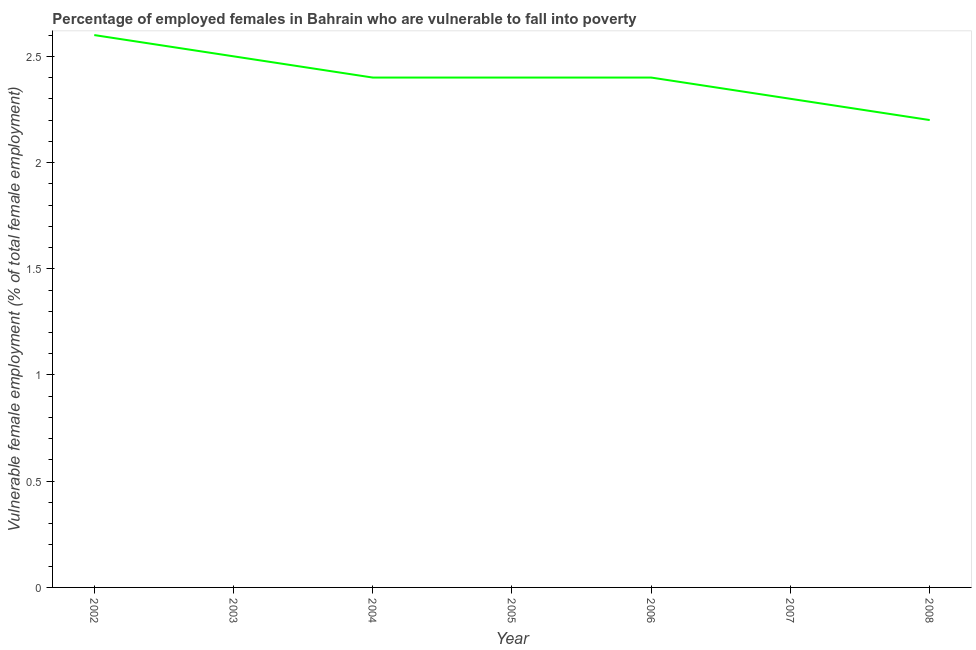What is the percentage of employed females who are vulnerable to fall into poverty in 2005?
Your answer should be compact. 2.4. Across all years, what is the maximum percentage of employed females who are vulnerable to fall into poverty?
Your response must be concise. 2.6. Across all years, what is the minimum percentage of employed females who are vulnerable to fall into poverty?
Your answer should be compact. 2.2. What is the sum of the percentage of employed females who are vulnerable to fall into poverty?
Keep it short and to the point. 16.8. What is the difference between the percentage of employed females who are vulnerable to fall into poverty in 2002 and 2006?
Provide a succinct answer. 0.2. What is the average percentage of employed females who are vulnerable to fall into poverty per year?
Provide a succinct answer. 2.4. What is the median percentage of employed females who are vulnerable to fall into poverty?
Your answer should be compact. 2.4. Do a majority of the years between 2006 and 2004 (inclusive) have percentage of employed females who are vulnerable to fall into poverty greater than 0.6 %?
Make the answer very short. No. What is the ratio of the percentage of employed females who are vulnerable to fall into poverty in 2007 to that in 2008?
Ensure brevity in your answer.  1.05. What is the difference between the highest and the second highest percentage of employed females who are vulnerable to fall into poverty?
Your answer should be compact. 0.1. What is the difference between the highest and the lowest percentage of employed females who are vulnerable to fall into poverty?
Your response must be concise. 0.4. In how many years, is the percentage of employed females who are vulnerable to fall into poverty greater than the average percentage of employed females who are vulnerable to fall into poverty taken over all years?
Your answer should be compact. 5. What is the difference between two consecutive major ticks on the Y-axis?
Offer a very short reply. 0.5. Does the graph contain any zero values?
Keep it short and to the point. No. Does the graph contain grids?
Your response must be concise. No. What is the title of the graph?
Offer a terse response. Percentage of employed females in Bahrain who are vulnerable to fall into poverty. What is the label or title of the X-axis?
Your answer should be very brief. Year. What is the label or title of the Y-axis?
Your response must be concise. Vulnerable female employment (% of total female employment). What is the Vulnerable female employment (% of total female employment) of 2002?
Your answer should be compact. 2.6. What is the Vulnerable female employment (% of total female employment) in 2004?
Provide a short and direct response. 2.4. What is the Vulnerable female employment (% of total female employment) in 2005?
Provide a short and direct response. 2.4. What is the Vulnerable female employment (% of total female employment) of 2006?
Your response must be concise. 2.4. What is the Vulnerable female employment (% of total female employment) in 2007?
Provide a succinct answer. 2.3. What is the Vulnerable female employment (% of total female employment) of 2008?
Ensure brevity in your answer.  2.2. What is the difference between the Vulnerable female employment (% of total female employment) in 2002 and 2003?
Ensure brevity in your answer.  0.1. What is the difference between the Vulnerable female employment (% of total female employment) in 2002 and 2004?
Offer a very short reply. 0.2. What is the difference between the Vulnerable female employment (% of total female employment) in 2002 and 2006?
Your answer should be compact. 0.2. What is the difference between the Vulnerable female employment (% of total female employment) in 2003 and 2004?
Offer a terse response. 0.1. What is the difference between the Vulnerable female employment (% of total female employment) in 2003 and 2006?
Provide a succinct answer. 0.1. What is the difference between the Vulnerable female employment (% of total female employment) in 2003 and 2007?
Your response must be concise. 0.2. What is the difference between the Vulnerable female employment (% of total female employment) in 2004 and 2006?
Offer a very short reply. 0. What is the difference between the Vulnerable female employment (% of total female employment) in 2004 and 2007?
Your answer should be compact. 0.1. What is the difference between the Vulnerable female employment (% of total female employment) in 2004 and 2008?
Give a very brief answer. 0.2. What is the difference between the Vulnerable female employment (% of total female employment) in 2005 and 2006?
Keep it short and to the point. 0. What is the difference between the Vulnerable female employment (% of total female employment) in 2005 and 2007?
Offer a terse response. 0.1. What is the difference between the Vulnerable female employment (% of total female employment) in 2005 and 2008?
Offer a terse response. 0.2. What is the ratio of the Vulnerable female employment (% of total female employment) in 2002 to that in 2003?
Provide a succinct answer. 1.04. What is the ratio of the Vulnerable female employment (% of total female employment) in 2002 to that in 2004?
Offer a very short reply. 1.08. What is the ratio of the Vulnerable female employment (% of total female employment) in 2002 to that in 2005?
Your response must be concise. 1.08. What is the ratio of the Vulnerable female employment (% of total female employment) in 2002 to that in 2006?
Your answer should be very brief. 1.08. What is the ratio of the Vulnerable female employment (% of total female employment) in 2002 to that in 2007?
Provide a succinct answer. 1.13. What is the ratio of the Vulnerable female employment (% of total female employment) in 2002 to that in 2008?
Make the answer very short. 1.18. What is the ratio of the Vulnerable female employment (% of total female employment) in 2003 to that in 2004?
Ensure brevity in your answer.  1.04. What is the ratio of the Vulnerable female employment (% of total female employment) in 2003 to that in 2005?
Offer a very short reply. 1.04. What is the ratio of the Vulnerable female employment (% of total female employment) in 2003 to that in 2006?
Provide a succinct answer. 1.04. What is the ratio of the Vulnerable female employment (% of total female employment) in 2003 to that in 2007?
Offer a terse response. 1.09. What is the ratio of the Vulnerable female employment (% of total female employment) in 2003 to that in 2008?
Provide a succinct answer. 1.14. What is the ratio of the Vulnerable female employment (% of total female employment) in 2004 to that in 2007?
Your response must be concise. 1.04. What is the ratio of the Vulnerable female employment (% of total female employment) in 2004 to that in 2008?
Make the answer very short. 1.09. What is the ratio of the Vulnerable female employment (% of total female employment) in 2005 to that in 2006?
Provide a succinct answer. 1. What is the ratio of the Vulnerable female employment (% of total female employment) in 2005 to that in 2007?
Ensure brevity in your answer.  1.04. What is the ratio of the Vulnerable female employment (% of total female employment) in 2005 to that in 2008?
Ensure brevity in your answer.  1.09. What is the ratio of the Vulnerable female employment (% of total female employment) in 2006 to that in 2007?
Keep it short and to the point. 1.04. What is the ratio of the Vulnerable female employment (% of total female employment) in 2006 to that in 2008?
Keep it short and to the point. 1.09. What is the ratio of the Vulnerable female employment (% of total female employment) in 2007 to that in 2008?
Your answer should be compact. 1.04. 